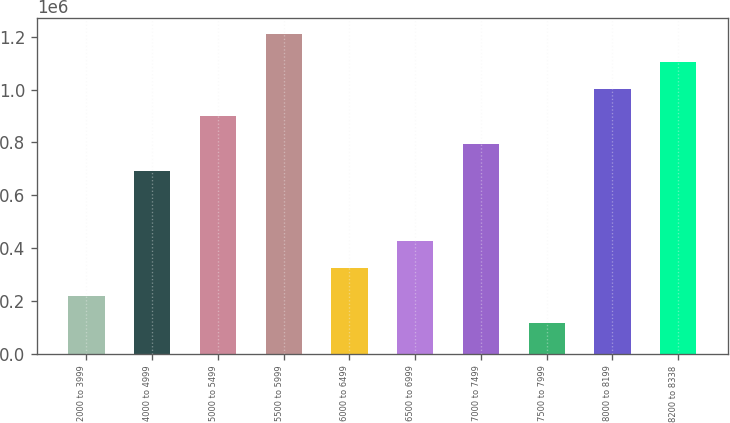Convert chart to OTSL. <chart><loc_0><loc_0><loc_500><loc_500><bar_chart><fcel>2000 to 3999<fcel>4000 to 4999<fcel>5000 to 5499<fcel>5500 to 5999<fcel>6000 to 6499<fcel>6500 to 6999<fcel>7000 to 7499<fcel>7500 to 7999<fcel>8000 to 8199<fcel>8200 to 8338<nl><fcel>219510<fcel>692261<fcel>899028<fcel>1.20918e+06<fcel>322893<fcel>426276<fcel>795644<fcel>116126<fcel>1.00241e+06<fcel>1.1058e+06<nl></chart> 